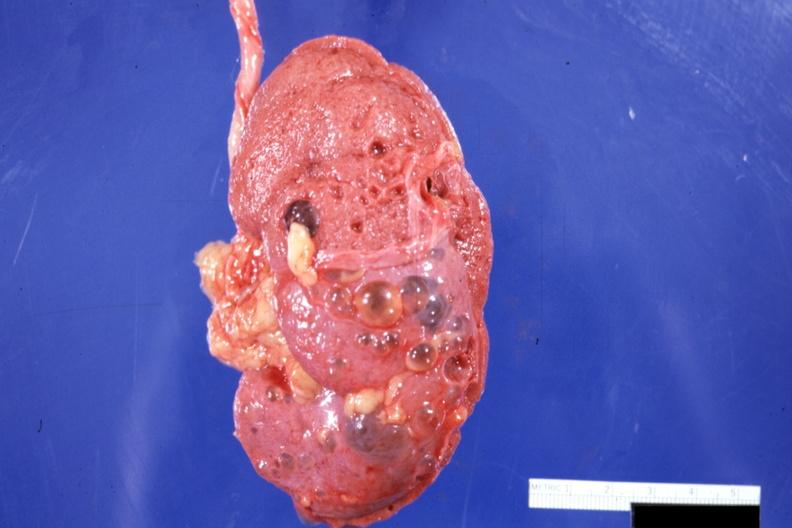what is present?
Answer the question using a single word or phrase. Multiple cysts 